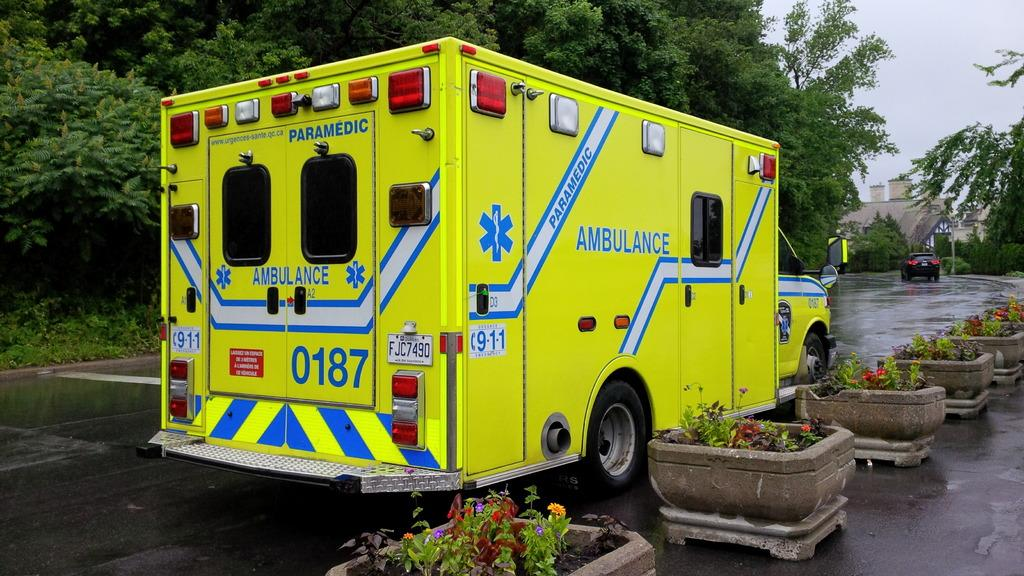What type of vehicles can be seen on the road in the image? There are motor vehicles on the road in the image. What other objects or elements can be seen in the image besides the vehicles? There are house plants, trees, buildings, and the sky visible in the image. How many boys are present in the image? There is no boy present in the image. What type of knee injury can be seen in the image? There is no knee injury present in the image. 